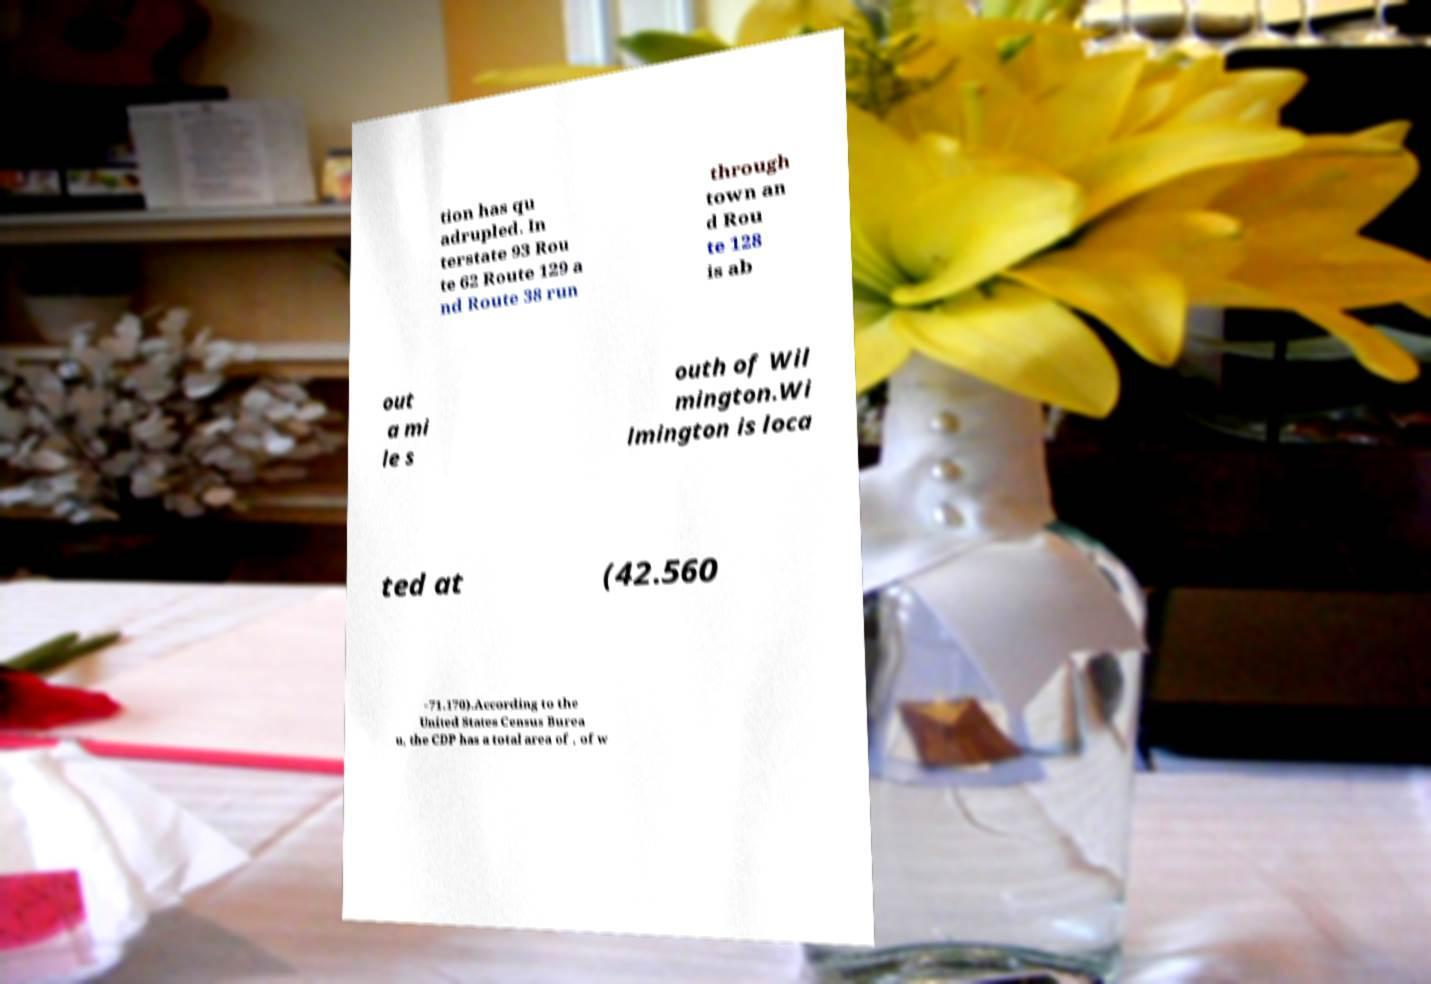What messages or text are displayed in this image? I need them in a readable, typed format. tion has qu adrupled. In terstate 93 Rou te 62 Route 129 a nd Route 38 run through town an d Rou te 128 is ab out a mi le s outh of Wil mington.Wi lmington is loca ted at (42.560 −71.170).According to the United States Census Burea u, the CDP has a total area of , of w 